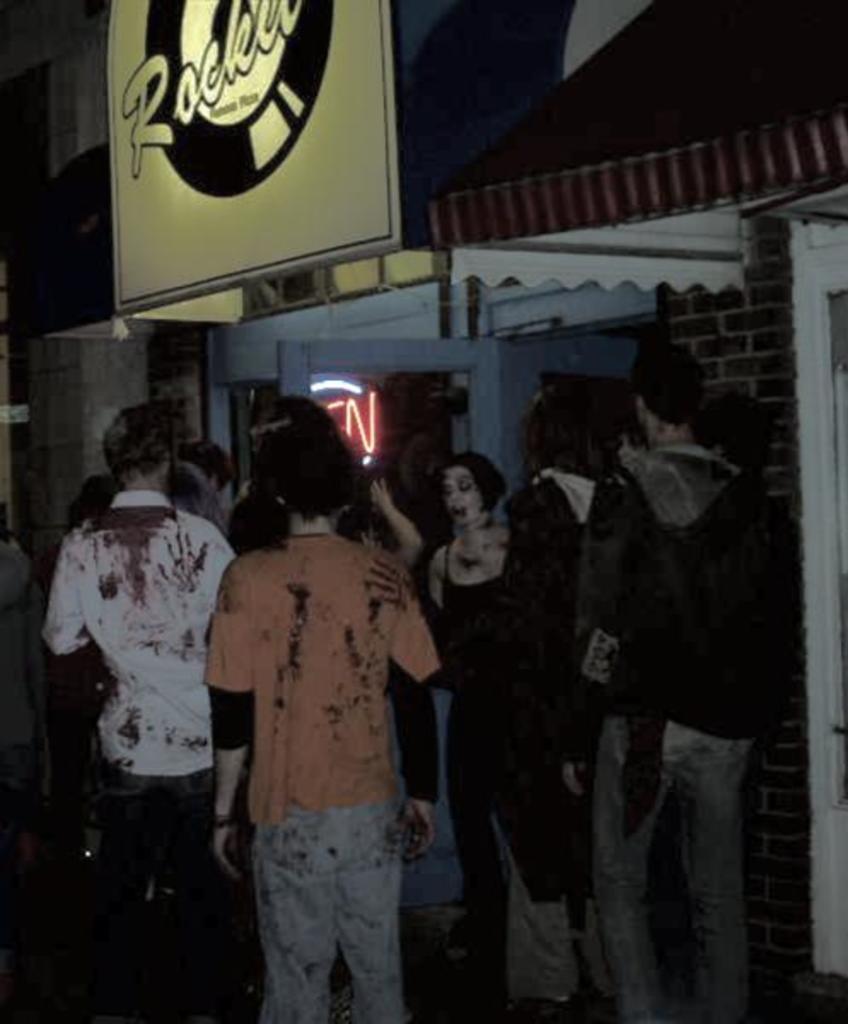Can you describe this image briefly? There are persons in different color dresses, standing. Above them, there is a hoarding. In the background, there is a building. 